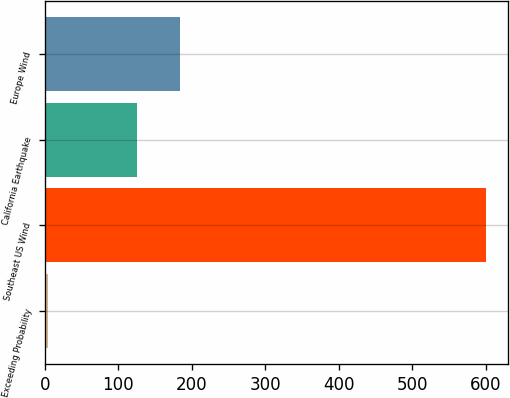Convert chart to OTSL. <chart><loc_0><loc_0><loc_500><loc_500><bar_chart><fcel>Exceeding Probability<fcel>Southeast US Wind<fcel>California Earthquake<fcel>Europe Wind<nl><fcel>5<fcel>600<fcel>125<fcel>184.5<nl></chart> 